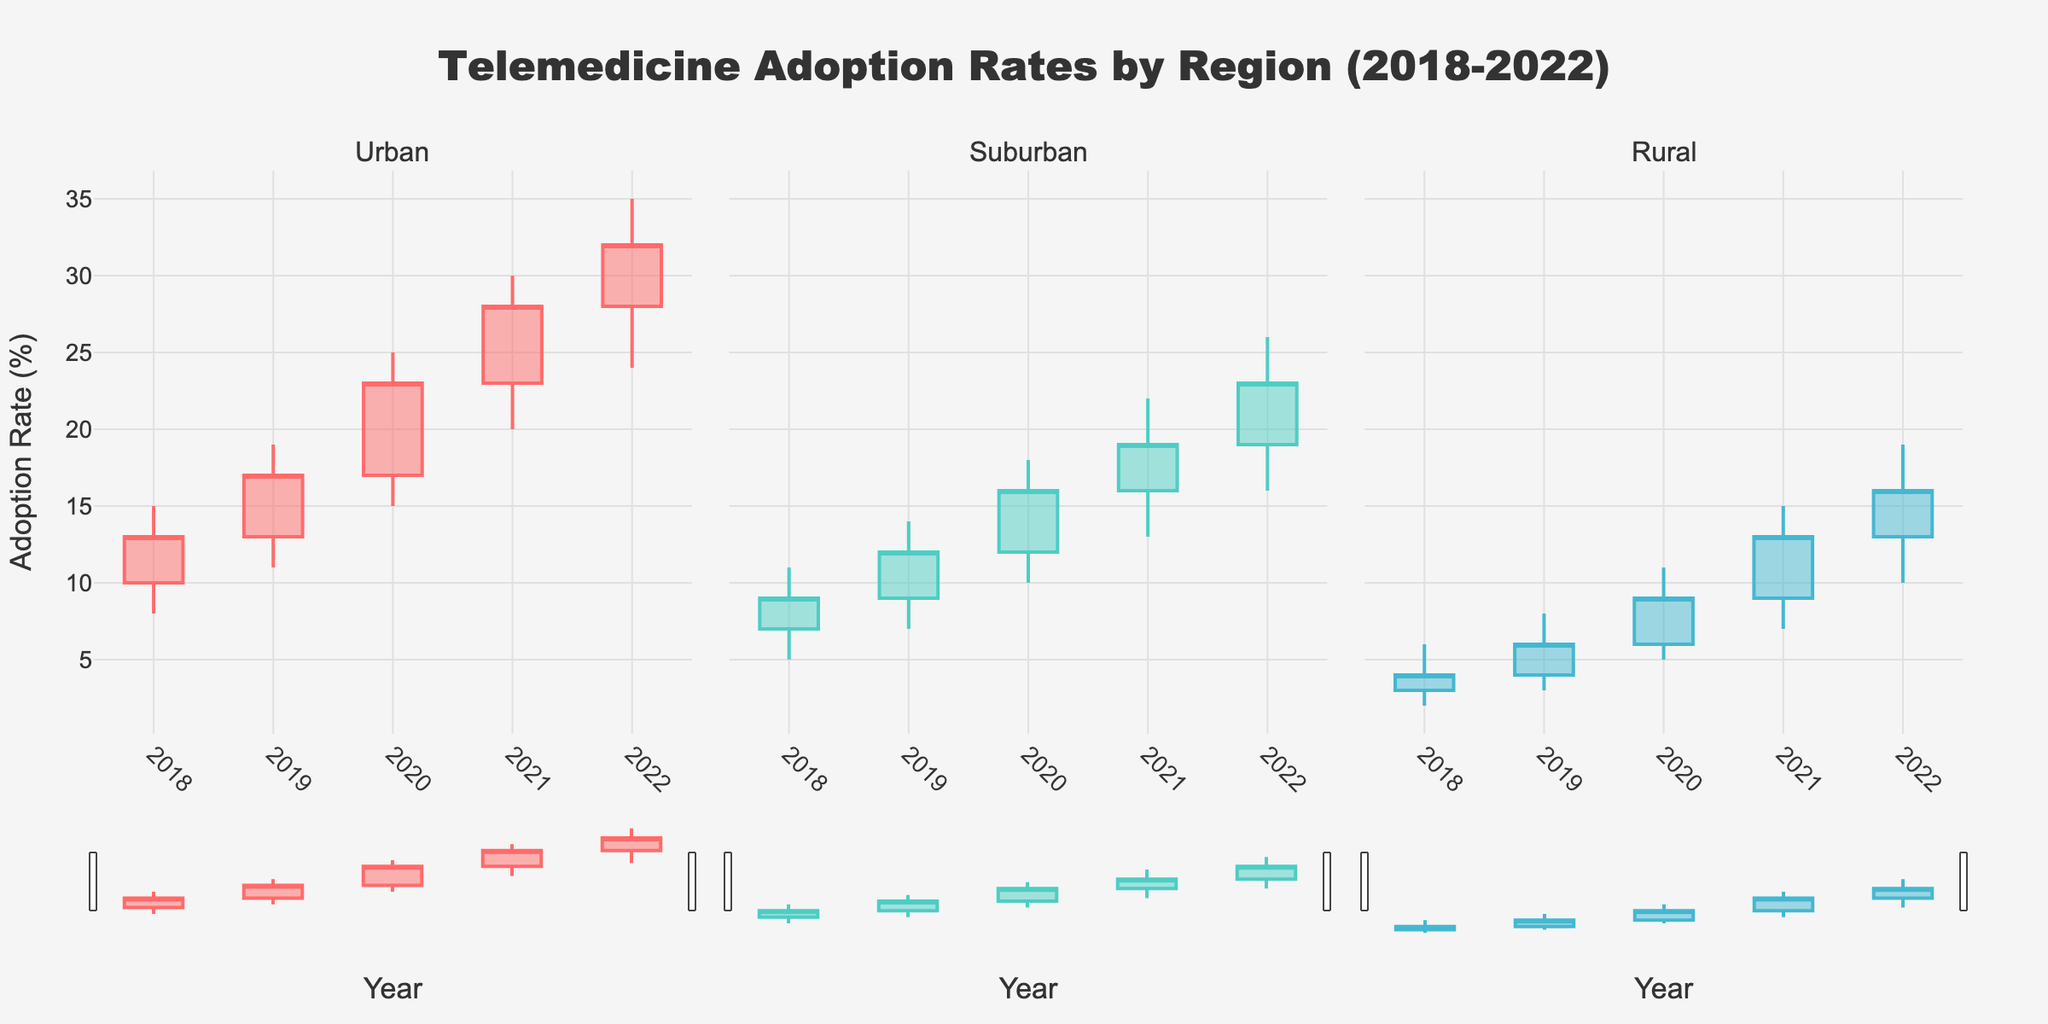What's the title of the figure? The title of a figure is usually found at the top, centered, in larger or bold font. In this case, it is indicated within the update_layout function with the key 'title'.
Answer: Telemedicine Adoption Rates by Region (2018-2022) How many regions are compared in the figure? The subplot titles in the make_subplots function indicate that there are three regions being compared.
Answer: 3 What is the highest adoption rate recorded for the rural region? To find the highest adoption rate for the rural region, observe the highest value ('High') in the rural candlestick plot over the years. In 2022, it reaches 19%.
Answer: 19% In which year did the urban region see its lowest adoption rate? The lowest adoption rate ('Low') of the urban region is found by comparing the lowest points over the years. It is in 2018 with 8%.
Answer: 2018 What was the urban region's adoption rate at the end of 2020? Check the 'Close' value for the urban region in 2020, which shows the rate at the end of the year. It is 23%.
Answer: 23% Which region had the smallest range of adoption rates in 2018? Calculate the range for each region in 2018 (High - Low): Urban (15-8 = 7), Suburban (11-5 = 6), Rural (6-2 = 4). The smallest range is 4.
Answer: Rural How did the closing adoption rate in the suburban region change from 2021 to 2022? Compare the 'Close' values of the suburban region for the years 2021 and 2022. The value changes from 19 in 2021 to 23 in 2022.
Answer: Increased by 4 Compare the highest adoption rates for the suburban and urban regions in 2022. Which is higher and by how much? Compare the 'High' values for suburban (26) and urban (35) regions in 2022. The urban region's value is higher by 9 (35 - 26).
Answer: Urban is higher by 9 What was the opening adoption rate for the rural region in 2019? 'Open' value indicates the starting rate for a year. For the rural region in 2019, it is 4%.
Answer: 4% Which region displayed a greater increase in adoption rate from 2018 to 2022, urban or rural? Calculate the difference in 'Close' values from 2018 to 2022 for both regions: Urban (32 - 13 = 19) and Rural (16 - 4 = 12). Urban has a greater increase by 7.
Answer: Urban 